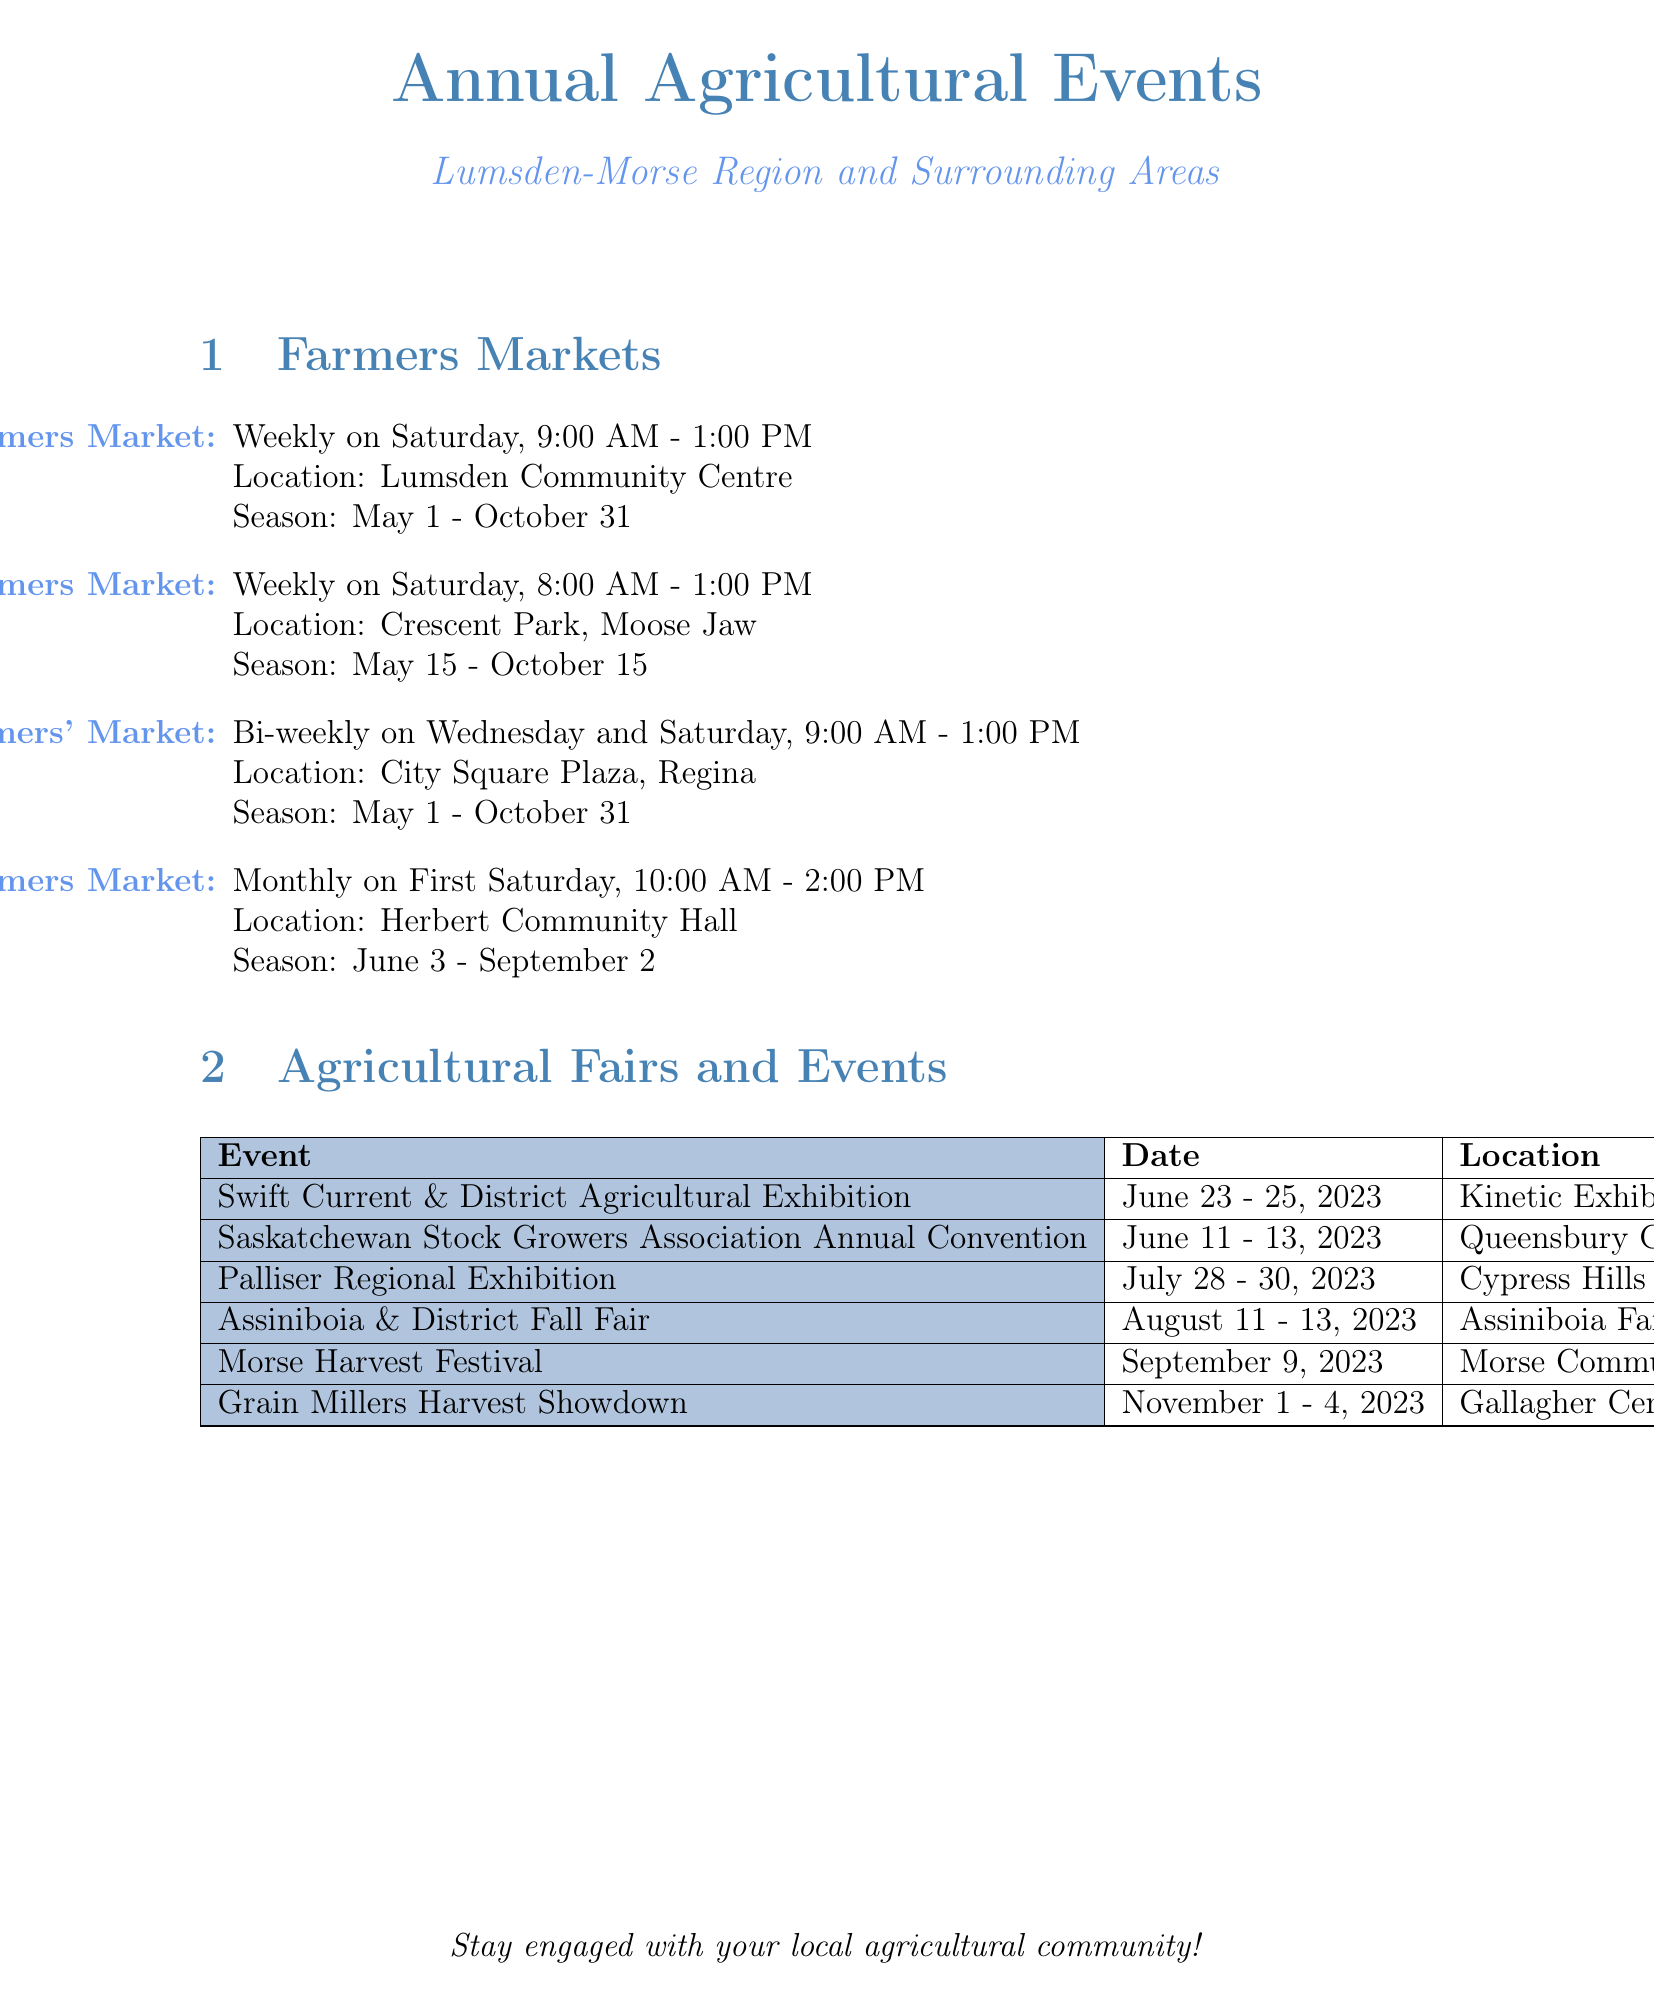What is the location of the Lumsden-Morse Farmers Market? The document lists the location of the Lumsden-Morse Farmers Market as Lumsden Community Centre.
Answer: Lumsden Community Centre What days is Regina's Farmers' Market held? The document states that Regina's Farmers' Market operates bi-weekly on Wednesday and Saturday.
Answer: Wednesday and Saturday When does the Moose Jaw Farmers Market operate? The document specifies the months during which the Moose Jaw Farmers Market operates, which is May 15 to October 15.
Answer: May 15 - October 15 What is the date range for the Swift Current & District Agricultural Exhibition? The document provides the date range for this event as June 23 to June 25, 2023.
Answer: June 23 - June 25, 2023 How often does the Herbert Farmers Market take place? According to the document, the Herbert Farmers Market occurs monthly on the first Saturday of the month.
Answer: Monthly Which agricultural fair occurs on September 9, 2023? The document identifies the Morse Harvest Festival as occurring on September 9, 2023.
Answer: Morse Harvest Festival What is the last agricultural event listed in the document? The last agricultural event mentioned in the document is the Grain Millers Harvest Showdown.
Answer: Grain Millers Harvest Showdown Where is the Palliser Regional Exhibition held? The document notes that the Palliser Regional Exhibition is held at Cypress Hills Fairgrounds, Maple Creek.
Answer: Cypress Hills Fairgrounds, Maple Creek 